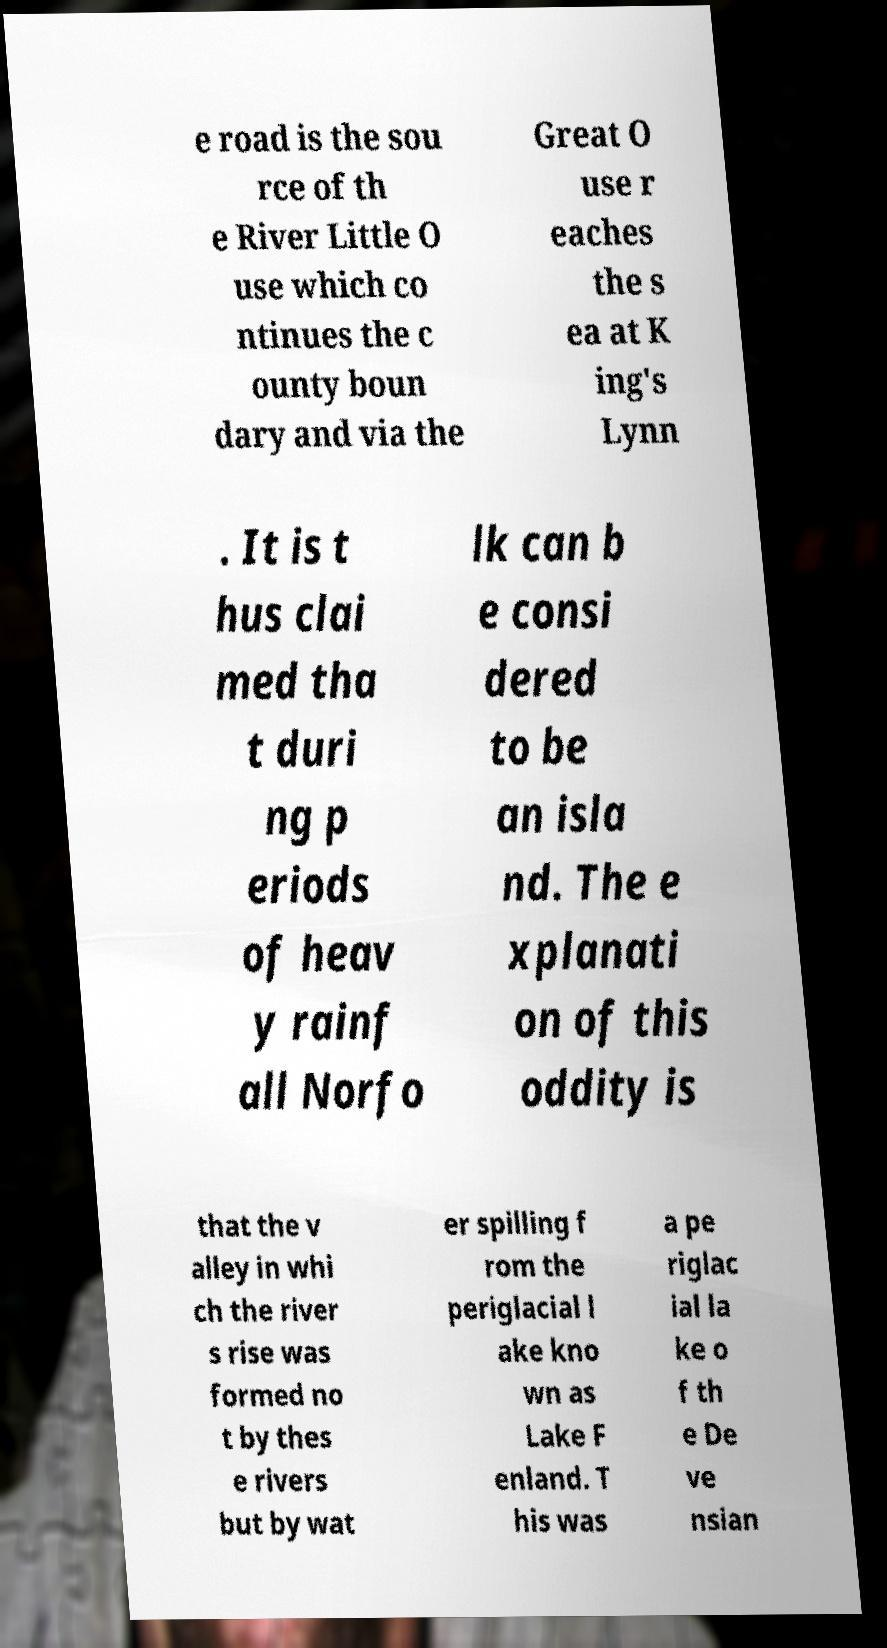Can you read and provide the text displayed in the image?This photo seems to have some interesting text. Can you extract and type it out for me? e road is the sou rce of th e River Little O use which co ntinues the c ounty boun dary and via the Great O use r eaches the s ea at K ing's Lynn . It is t hus clai med tha t duri ng p eriods of heav y rainf all Norfo lk can b e consi dered to be an isla nd. The e xplanati on of this oddity is that the v alley in whi ch the river s rise was formed no t by thes e rivers but by wat er spilling f rom the periglacial l ake kno wn as Lake F enland. T his was a pe riglac ial la ke o f th e De ve nsian 